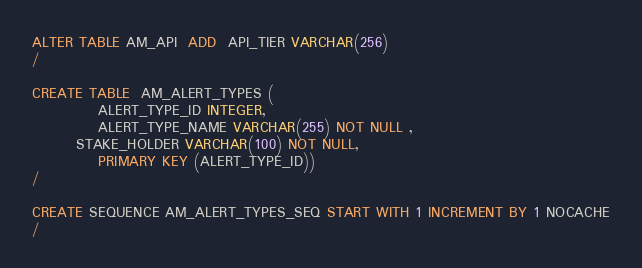Convert code to text. <code><loc_0><loc_0><loc_500><loc_500><_SQL_>ALTER TABLE AM_API  ADD  API_TIER VARCHAR(256)
/

CREATE TABLE  AM_ALERT_TYPES (
            ALERT_TYPE_ID INTEGER,
            ALERT_TYPE_NAME VARCHAR(255) NOT NULL ,
	    STAKE_HOLDER VARCHAR(100) NOT NULL,
            PRIMARY KEY (ALERT_TYPE_ID))
/

CREATE SEQUENCE AM_ALERT_TYPES_SEQ START WITH 1 INCREMENT BY 1 NOCACHE
/
</code> 